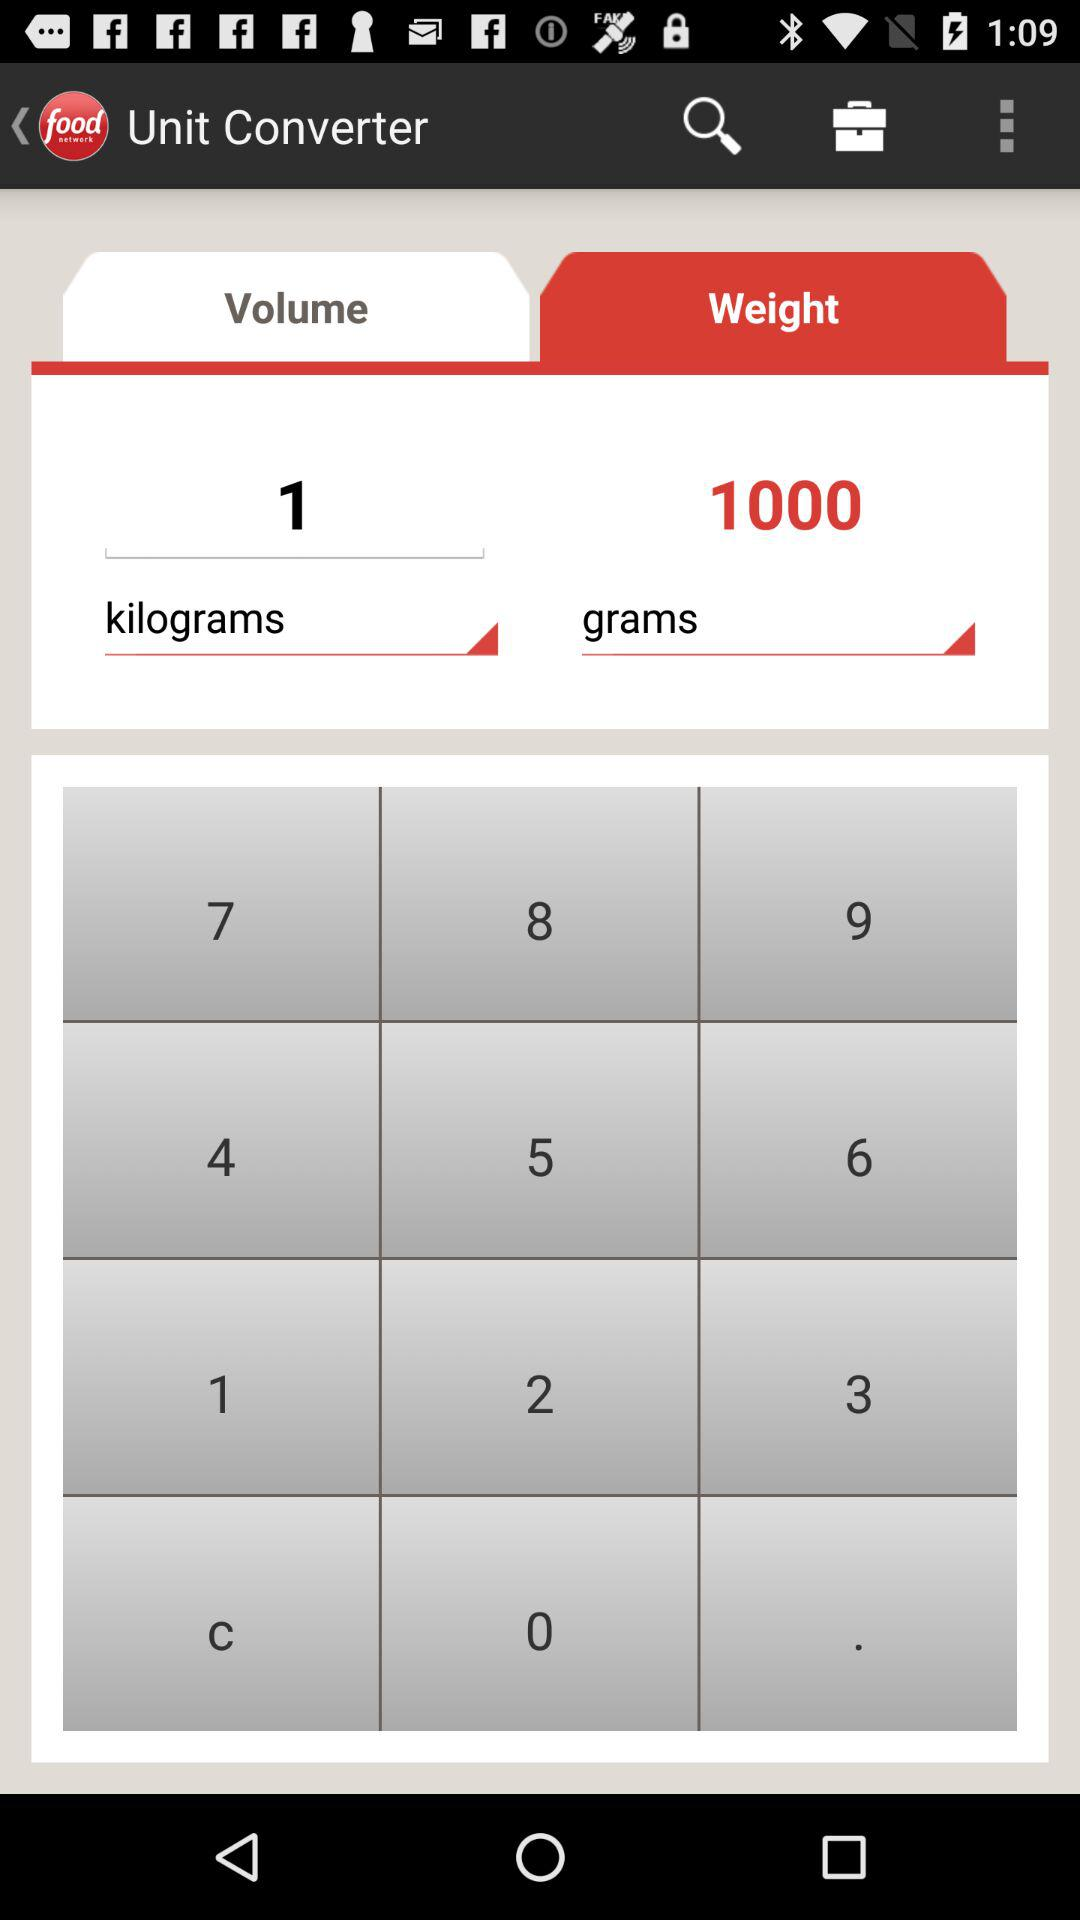How much is 1 kilogram in grams?
Answer the question using a single word or phrase. 1000 